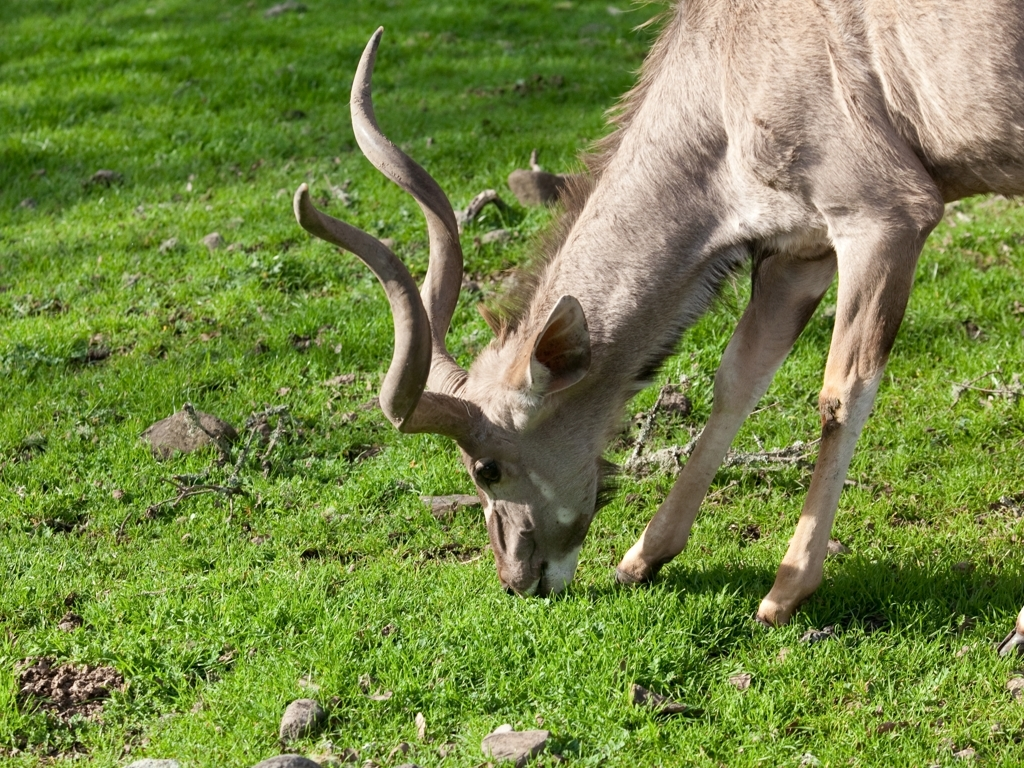What kind of environment is the deer in? The deer is grazing in an area that looks like a lush meadow with vibrant green grass, indicating a healthy ecosystem possibly within a protected park or a wildlife reserve. 